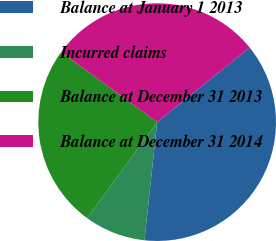Convert chart to OTSL. <chart><loc_0><loc_0><loc_500><loc_500><pie_chart><fcel>Balance at January 1 2013<fcel>Incurred claims<fcel>Balance at December 31 2013<fcel>Balance at December 31 2014<nl><fcel>37.5%<fcel>8.33%<fcel>25.0%<fcel>29.17%<nl></chart> 